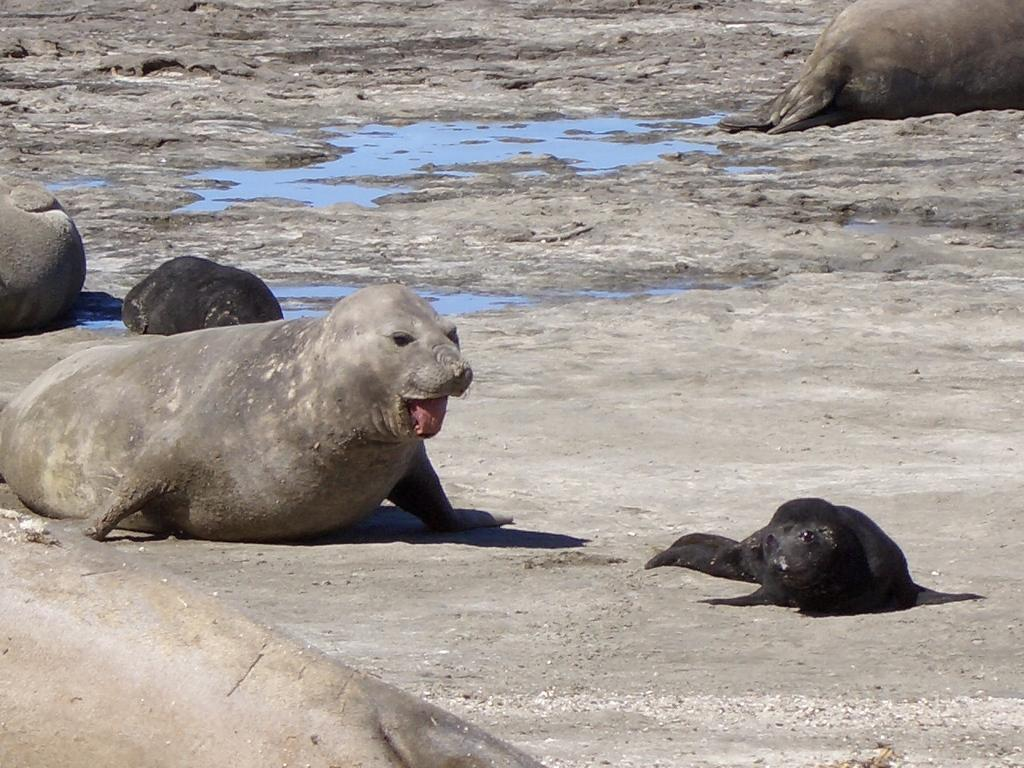What animals are present in the image? There is a group of seals on the ground. What type of terrain can be seen in the image? There are stones visible in the image. What natural element is present in the image? There is water visible in the image. What type of collar can be seen on the seals in the image? There are no collars present on the seals in the image. How many boys are visible in the image? There are no boys present in the image; it features a group of seals. 